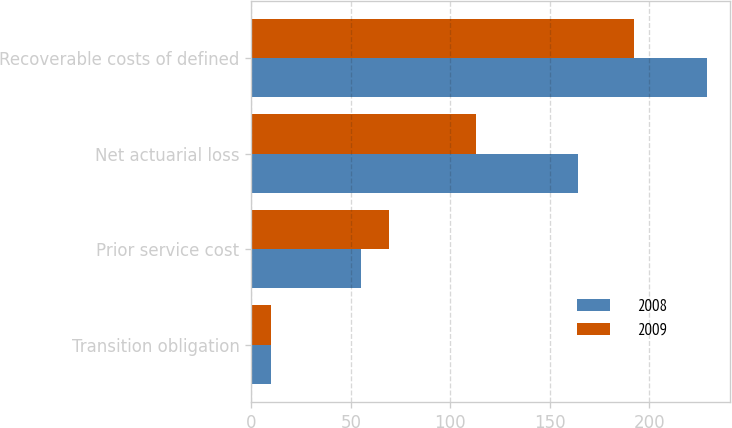Convert chart to OTSL. <chart><loc_0><loc_0><loc_500><loc_500><stacked_bar_chart><ecel><fcel>Transition obligation<fcel>Prior service cost<fcel>Net actuarial loss<fcel>Recoverable costs of defined<nl><fcel>2008<fcel>10<fcel>55<fcel>164<fcel>229<nl><fcel>2009<fcel>10<fcel>69<fcel>113<fcel>192<nl></chart> 